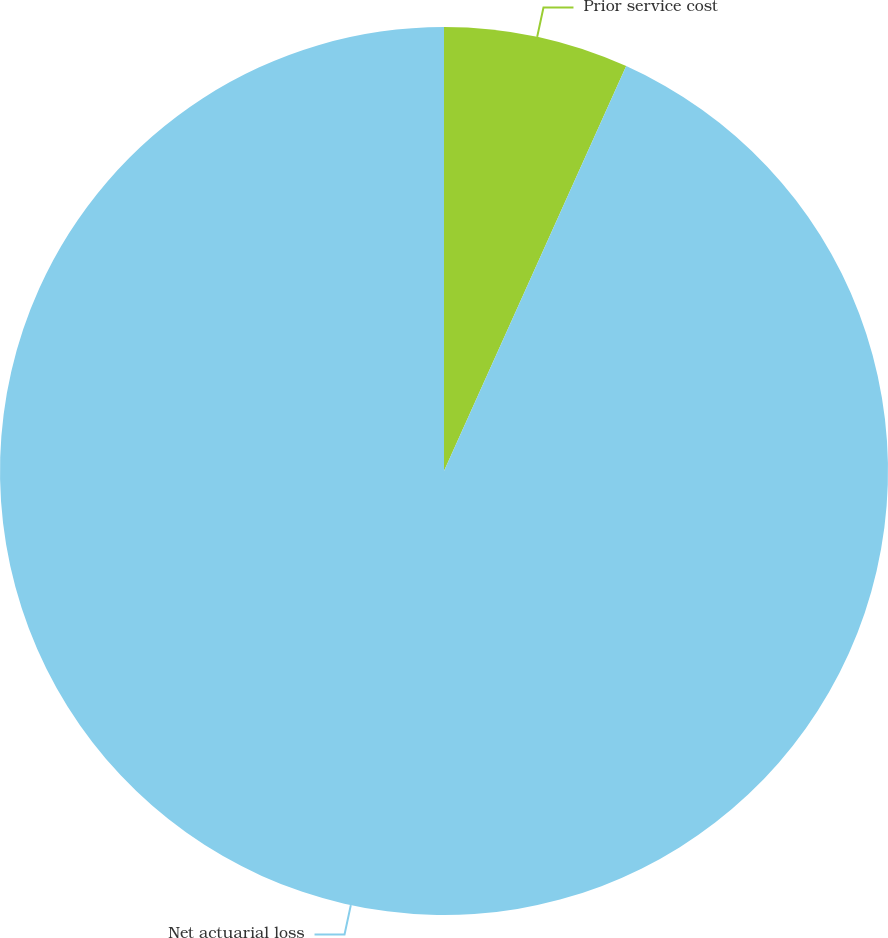Convert chart. <chart><loc_0><loc_0><loc_500><loc_500><pie_chart><fcel>Prior service cost<fcel>Net actuarial loss<nl><fcel>6.73%<fcel>93.27%<nl></chart> 